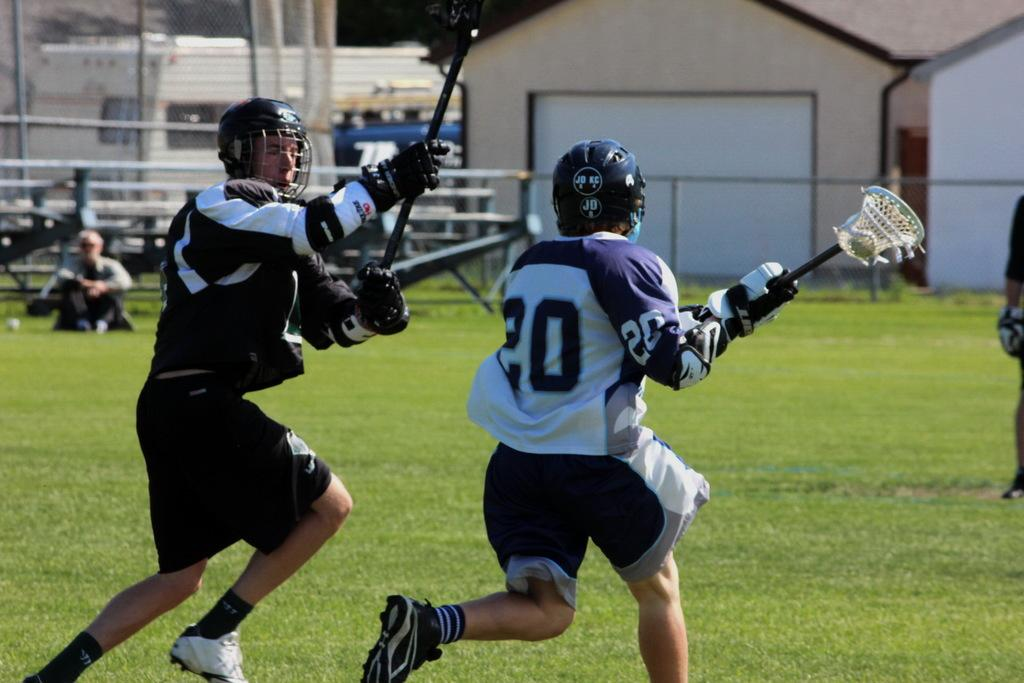What is happening in the foreground of the picture? There are players playing in the foreground of the picture. What type of surface are the players on? There is grass in the foreground of the picture. What can be seen in the background of the picture? There are buildings, a railing, and branches in the background of the picture. Are there any people visible in the background? Yes, there is a person in the background of the picture. What type of pot is being used by the players in the picture? There is no pot present in the picture; the players are playing on a grassy surface. What is the title of the game being played in the picture? The provided facts do not mention a title for the game being played in the picture. 